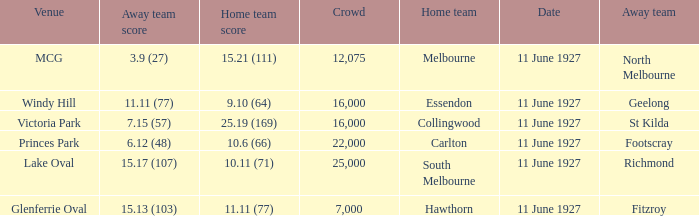Would you be able to parse every entry in this table? {'header': ['Venue', 'Away team score', 'Home team score', 'Crowd', 'Home team', 'Date', 'Away team'], 'rows': [['MCG', '3.9 (27)', '15.21 (111)', '12,075', 'Melbourne', '11 June 1927', 'North Melbourne'], ['Windy Hill', '11.11 (77)', '9.10 (64)', '16,000', 'Essendon', '11 June 1927', 'Geelong'], ['Victoria Park', '7.15 (57)', '25.19 (169)', '16,000', 'Collingwood', '11 June 1927', 'St Kilda'], ['Princes Park', '6.12 (48)', '10.6 (66)', '22,000', 'Carlton', '11 June 1927', 'Footscray'], ['Lake Oval', '15.17 (107)', '10.11 (71)', '25,000', 'South Melbourne', '11 June 1927', 'Richmond'], ['Glenferrie Oval', '15.13 (103)', '11.11 (77)', '7,000', 'Hawthorn', '11 June 1927', 'Fitzroy']]} What is the sum of all crowds present at the Glenferrie Oval venue? 7000.0. 